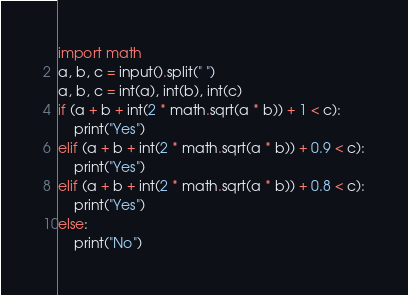Convert code to text. <code><loc_0><loc_0><loc_500><loc_500><_Python_>import math
a, b, c = input().split(" ")
a, b, c = int(a), int(b), int(c)
if (a + b + int(2 * math.sqrt(a * b)) + 1 < c):
    print("Yes")
elif (a + b + int(2 * math.sqrt(a * b)) + 0.9 < c):
    print("Yes")
elif (a + b + int(2 * math.sqrt(a * b)) + 0.8 < c):
    print("Yes")
else:
    print("No")
</code> 